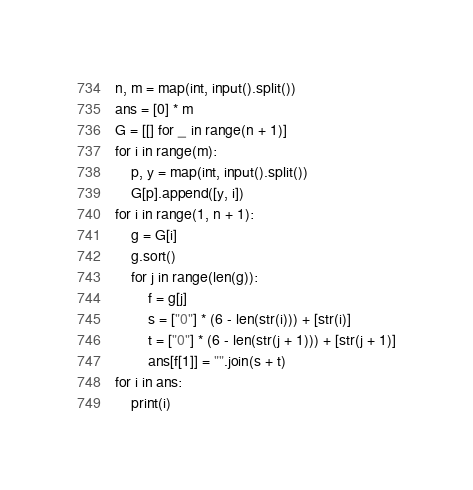Convert code to text. <code><loc_0><loc_0><loc_500><loc_500><_Python_>n, m = map(int, input().split())
ans = [0] * m
G = [[] for _ in range(n + 1)]
for i in range(m):
    p, y = map(int, input().split())
    G[p].append([y, i])
for i in range(1, n + 1):
    g = G[i]
    g.sort()
    for j in range(len(g)):
        f = g[j]
        s = ["0"] * (6 - len(str(i))) + [str(i)]
        t = ["0"] * (6 - len(str(j + 1))) + [str(j + 1)]
        ans[f[1]] = "".join(s + t)
for i in ans:
    print(i)</code> 